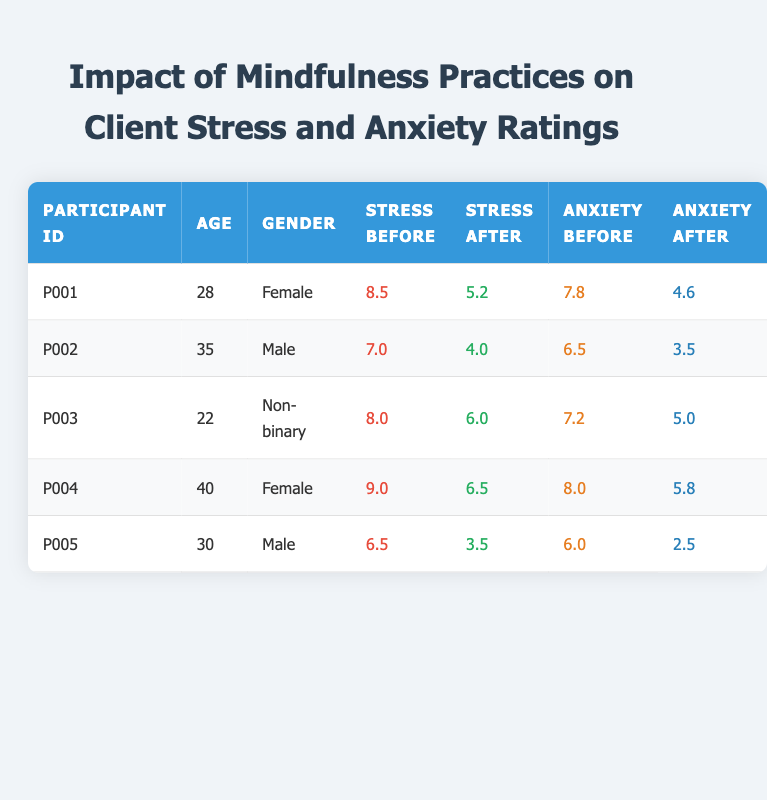What is the stress rating of participant P001 before mindfulness practice? The stress rating for participant P001 before mindfulness practice is found in the "BeforeMindfulnessStressRating" column for that participant. It shows a value of 8.5.
Answer: 8.5 What is the gender of participant P004? The gender of participant P004 can be found in the "Gender" column for that participant. The entry shows "Female."
Answer: Female What was the average anxiety rating before mindfulness practices for all participants? To find the average anxiety rating before mindfulness practices, sum the "BeforeMindfulnessAnxietyRating" values: (7.8 + 6.5 + 7.2 + 8.0 + 6.0) = 35.5. Then divide by the number of participants (5), which gives 35.5 / 5 = 7.1.
Answer: 7.1 Did participant P002 experience a greater reduction in anxiety or stress ratings after mindfulness practices? Participant P002 had both "AfterMindfulnessStressRating" of 4.0 and "AfterMindfulnessAnxietyRating" of 3.5. The reduction in stress is (7.0 - 4.0) = 3.0, and the reduction in anxiety is (6.5 - 3.5) = 3.0. Both reductions are equal.
Answer: No Which participant had the highest stress rating before mindfulness practices? To find the participant with the highest stress rating, we compare all values in the "BeforeMindfulnessStressRating" column: 8.5, 7.0, 8.0, 9.0, and 6.5. The highest value is 9.0, which belongs to participant P004.
Answer: P004 How much did the anxiety rating decrease for the participant with the lowest stress after mindfulness practice? The participant with the lowest stress rating after mindfulness practices is P005, with an "AfterMindfulnessStressRating" of 3.5. The "AfterMindfulnessAnxietyRating" for P005 is 2.5. To find the decrease, we calculate the difference between "BeforeMindfulnessAnxietyRating" (6.0) and "AfterMindfulnessAnxietyRating" (2.5): 6.0 - 2.5 = 3.5.
Answer: 3.5 Was there a participant who had a higher stress rating before mindfulness practices than after practices? All participants show a decrease in stress after mindfulness practices: P001 (8.5 to 5.2), P002 (7.0 to 4.0), P003 (8.0 to 6.0), P004 (9.0 to 6.5), and P005 (6.5 to 3.5). Thus, every participant had a higher rating before.
Answer: Yes What is the difference in anxiety ratings for participant P003 before and after mindfulness? Participant P003 shows a "BeforeMindfulnessAnxietyRating" of 7.2 and an "AfterMindfulnessAnxietyRating" of 5.0. To find the difference, subtract the after rating from the before: 7.2 - 5.0 = 2.2.
Answer: 2.2 